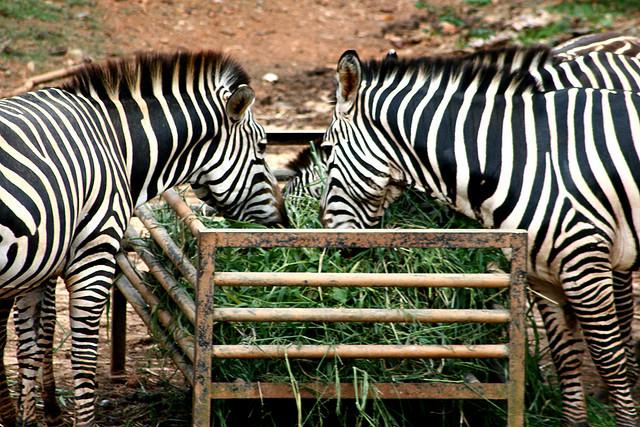Are the zebras in the wild?
Concise answer only. No. What are they eating?
Concise answer only. Hay. Are the zebras eating greeneries?
Short answer required. Yes. 